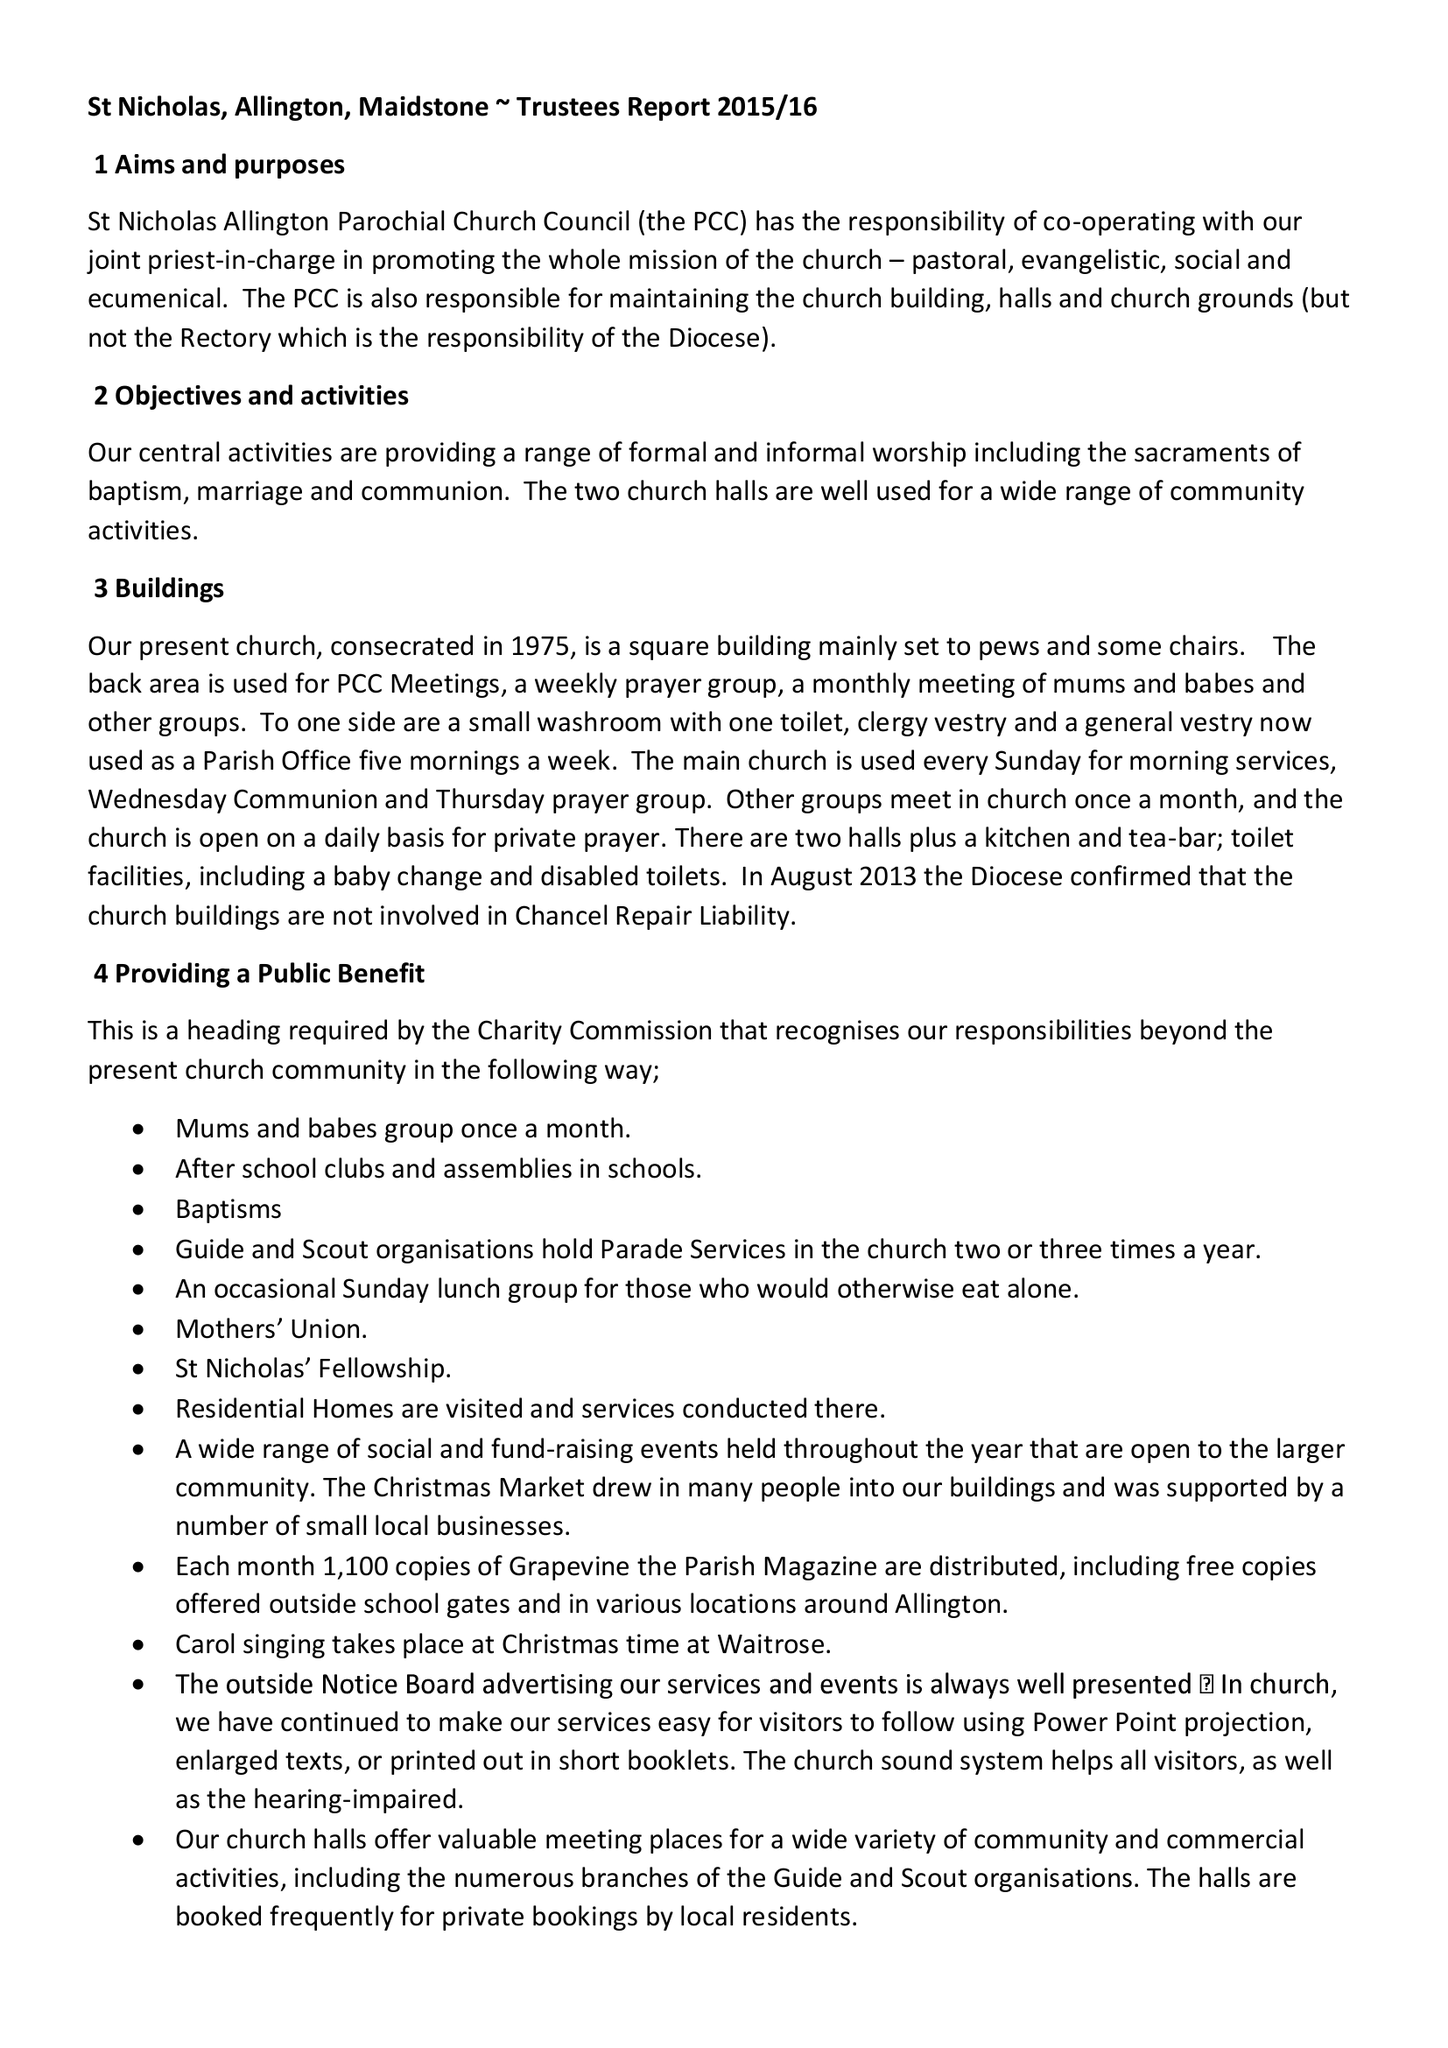What is the value for the charity_name?
Answer the question using a single word or phrase. Parochial Church Council Of The Ecclesiastical Parish Of Allington, St Nicholas With Maidstone, St Peter, Maidstone 